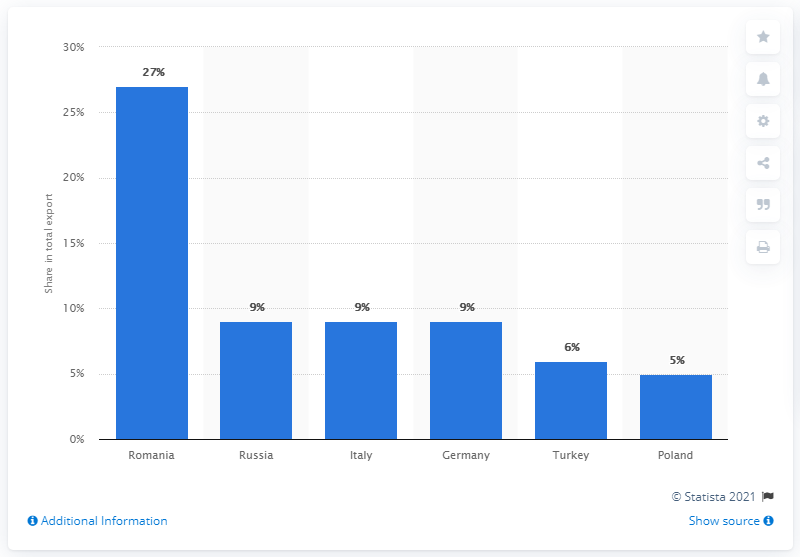Indicate a few pertinent items in this graphic. Moldova's most important export partner in 2019 was Romania. 